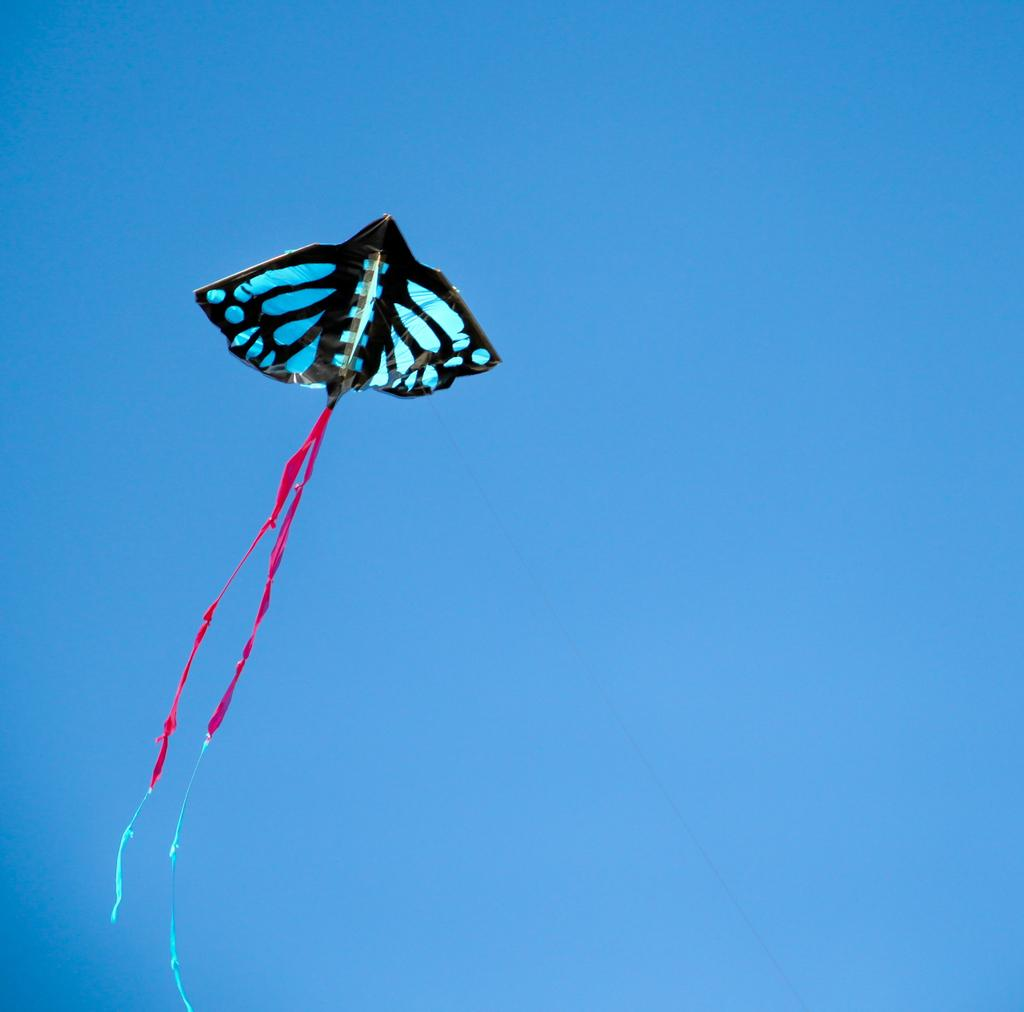What is visible in the sky in the image? There is a kite in the sky in the image. What type of form or structure can be seen on the ground in the image? There is no specific form or structure mentioned on the ground in the image; it only features a kite in the sky. Can you see any buildings in the image? The provided facts do not mention any buildings in the image; it only features a kite in the sky. 